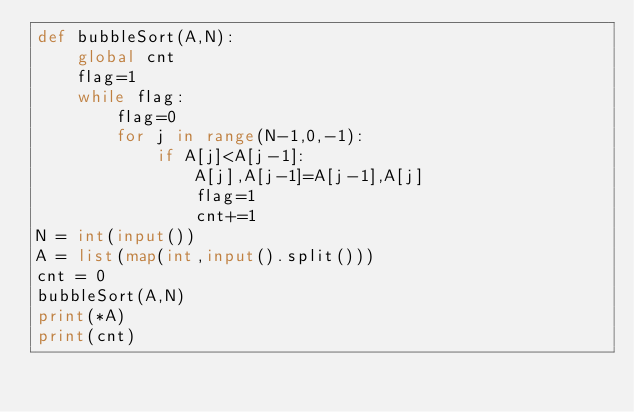Convert code to text. <code><loc_0><loc_0><loc_500><loc_500><_Python_>def bubbleSort(A,N):
    global cnt
    flag=1
    while flag:
        flag=0
        for j in range(N-1,0,-1):
            if A[j]<A[j-1]:
                A[j],A[j-1]=A[j-1],A[j]
                flag=1
                cnt+=1
N = int(input())
A = list(map(int,input().split()))
cnt = 0
bubbleSort(A,N)
print(*A)
print(cnt)
</code> 